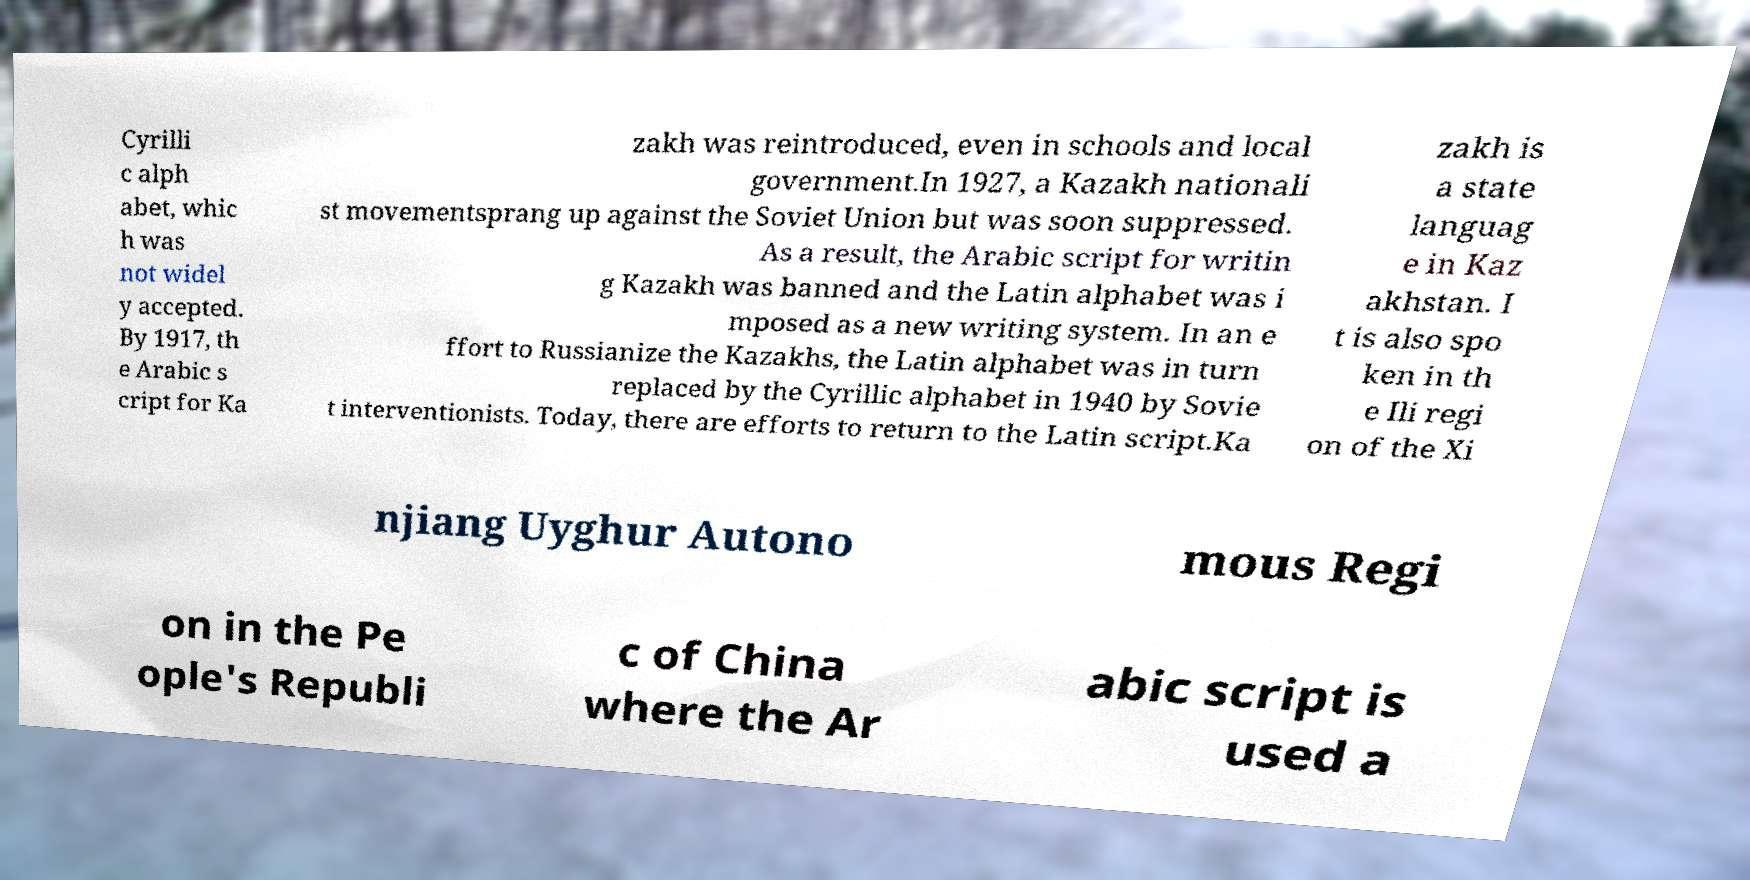Please read and relay the text visible in this image. What does it say? Cyrilli c alph abet, whic h was not widel y accepted. By 1917, th e Arabic s cript for Ka zakh was reintroduced, even in schools and local government.In 1927, a Kazakh nationali st movementsprang up against the Soviet Union but was soon suppressed. As a result, the Arabic script for writin g Kazakh was banned and the Latin alphabet was i mposed as a new writing system. In an e ffort to Russianize the Kazakhs, the Latin alphabet was in turn replaced by the Cyrillic alphabet in 1940 by Sovie t interventionists. Today, there are efforts to return to the Latin script.Ka zakh is a state languag e in Kaz akhstan. I t is also spo ken in th e Ili regi on of the Xi njiang Uyghur Autono mous Regi on in the Pe ople's Republi c of China where the Ar abic script is used a 